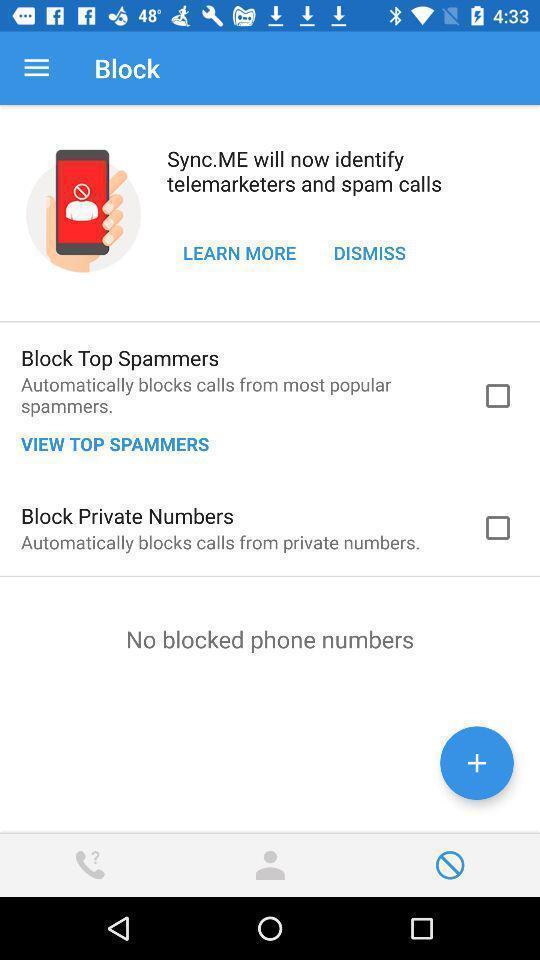Describe the content in this image. Screen page displaying various options in calls blocking application. 